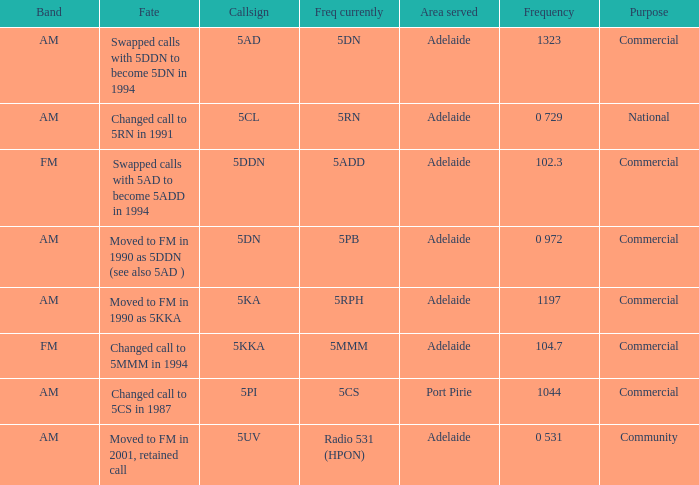What is the purpose for Frequency of 102.3? Commercial. 